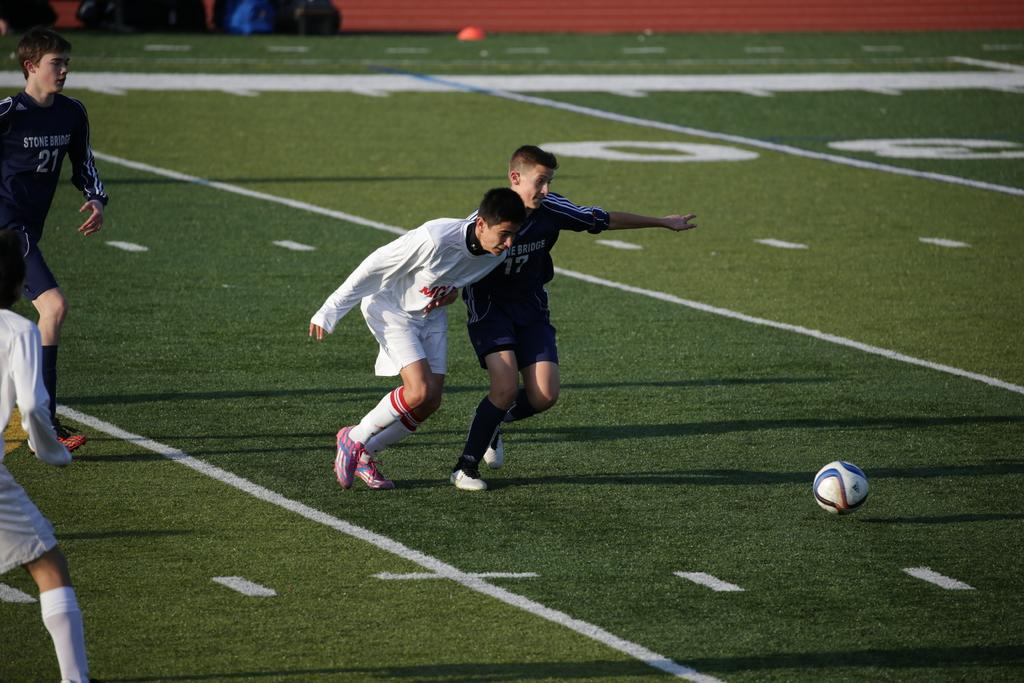What are the people in the image doing? The people in the image are playing football. Where is the football game taking place? The football game is taking place on a ground. What sport are the players engaged in? The players are playing football. What type of meat is being grilled on the sidelines of the football game? There is no meat or grilling activity present in the image; it only shows a football game taking place on a ground. 